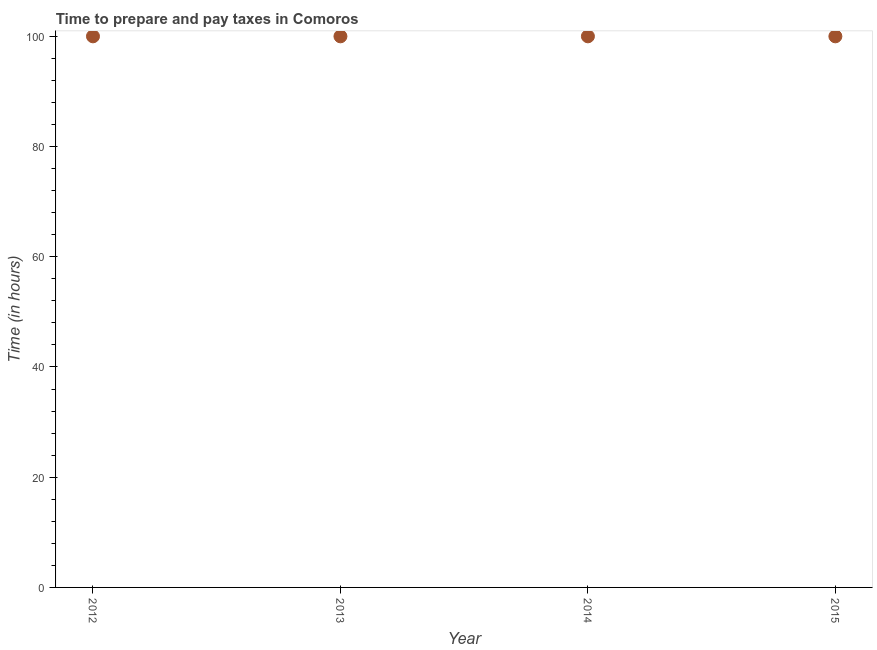What is the time to prepare and pay taxes in 2012?
Your answer should be very brief. 100. Across all years, what is the maximum time to prepare and pay taxes?
Give a very brief answer. 100. Across all years, what is the minimum time to prepare and pay taxes?
Provide a succinct answer. 100. In which year was the time to prepare and pay taxes maximum?
Offer a terse response. 2012. What is the sum of the time to prepare and pay taxes?
Your answer should be very brief. 400. What is the average time to prepare and pay taxes per year?
Ensure brevity in your answer.  100. In how many years, is the time to prepare and pay taxes greater than 16 hours?
Your response must be concise. 4. Do a majority of the years between 2013 and 2014 (inclusive) have time to prepare and pay taxes greater than 44 hours?
Provide a short and direct response. Yes. What is the difference between the highest and the second highest time to prepare and pay taxes?
Offer a terse response. 0. What is the difference between the highest and the lowest time to prepare and pay taxes?
Your response must be concise. 0. In how many years, is the time to prepare and pay taxes greater than the average time to prepare and pay taxes taken over all years?
Provide a short and direct response. 0. How many dotlines are there?
Your answer should be compact. 1. How many years are there in the graph?
Your answer should be very brief. 4. Does the graph contain any zero values?
Make the answer very short. No. What is the title of the graph?
Give a very brief answer. Time to prepare and pay taxes in Comoros. What is the label or title of the Y-axis?
Make the answer very short. Time (in hours). What is the difference between the Time (in hours) in 2012 and 2014?
Provide a succinct answer. 0. What is the difference between the Time (in hours) in 2012 and 2015?
Offer a terse response. 0. What is the difference between the Time (in hours) in 2013 and 2014?
Your response must be concise. 0. What is the ratio of the Time (in hours) in 2012 to that in 2014?
Give a very brief answer. 1. What is the ratio of the Time (in hours) in 2012 to that in 2015?
Give a very brief answer. 1. What is the ratio of the Time (in hours) in 2013 to that in 2014?
Provide a succinct answer. 1. 